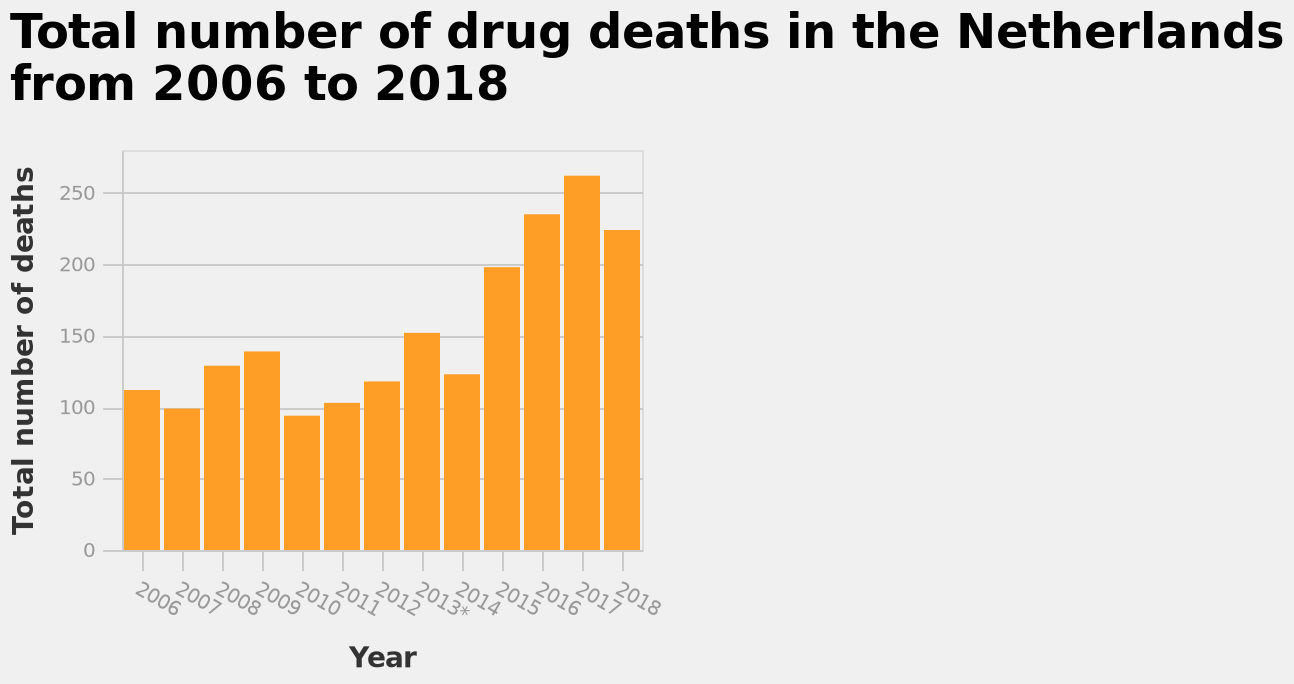<image>
please describe the details of the chart Total number of drug deaths in the Netherlands from 2006 to 2018 is a bar chart. The x-axis plots Year as linear scale of range 2006 to 2018 while the y-axis plots Total number of deaths on linear scale with a minimum of 0 and a maximum of 250. Offer a thorough analysis of the image. The number of drug deaths has increased by roughly double from 2006 to 2018. There was a dip in deaths between 2010 and 2014. What is the trend of drug deaths in the Netherlands from 2006 to 2018 based on the bar chart? The bar chart does not provide information about the trend of drug deaths over the specified time period. 